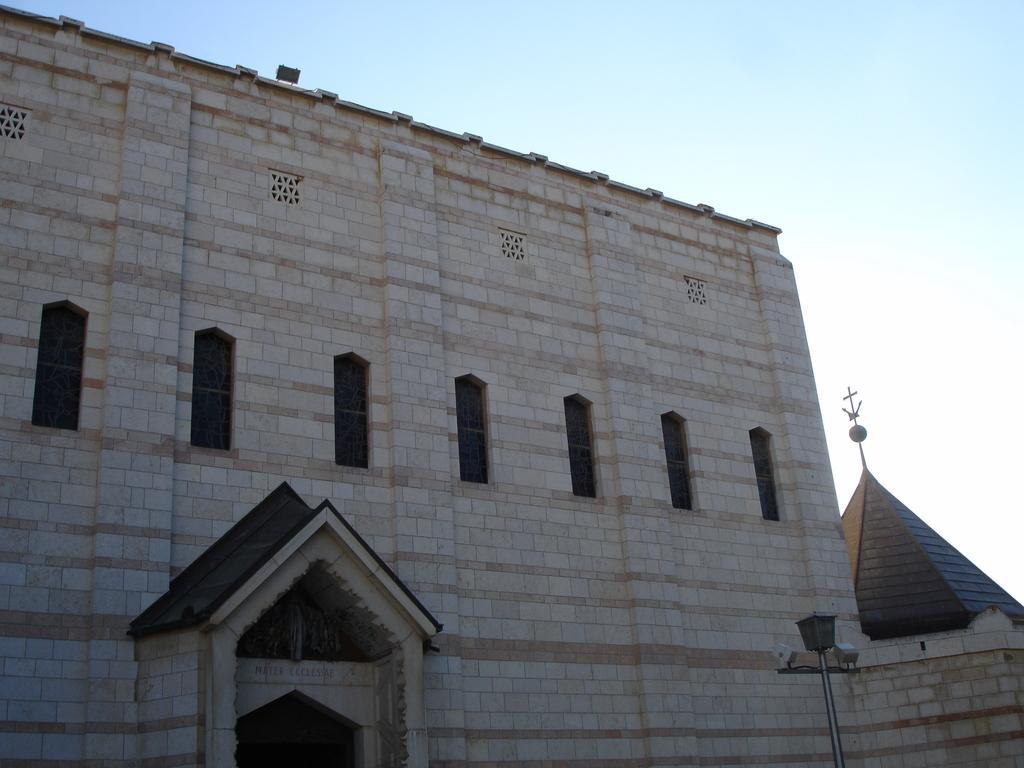How would you summarize this image in a sentence or two? In this picture we can see a building with windows, pole and in the background we can see the sky. 